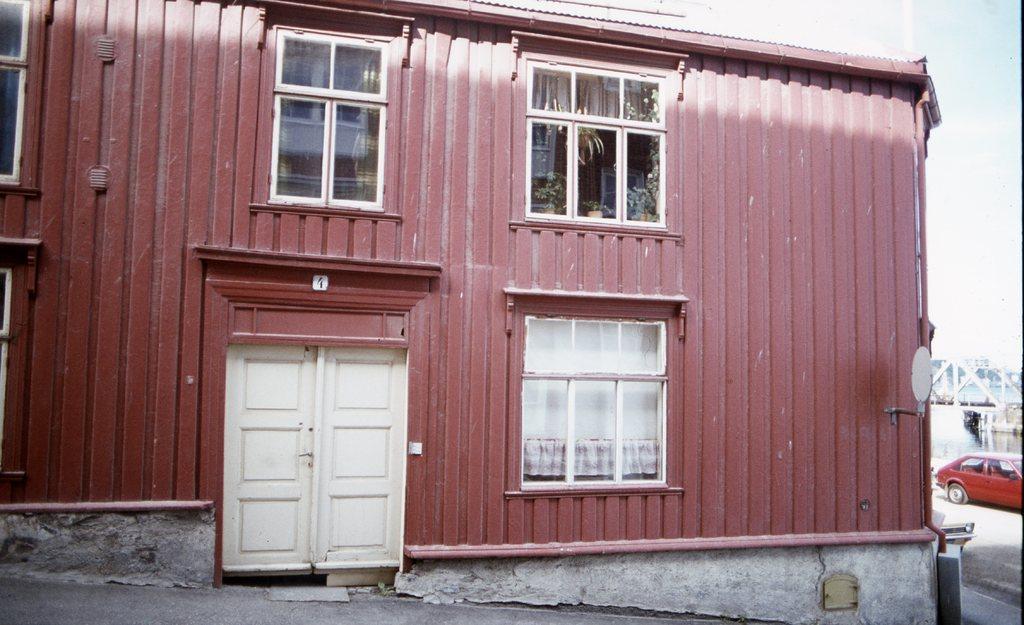Can you describe this image briefly? In this picture we can see a house in the front, on the right side there is a red color car, we can see windows and a door of this house, there is the sky at the top of the picture, in the background we can see water. 